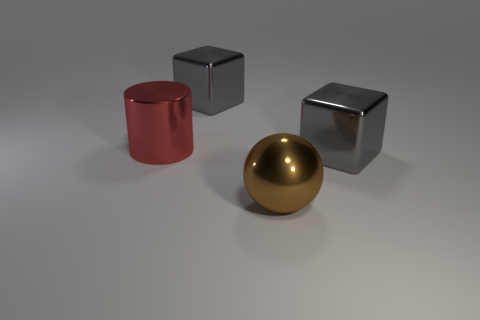Add 2 big red metal objects. How many objects exist? 6 Subtract all cylinders. How many objects are left? 3 Subtract 0 yellow balls. How many objects are left? 4 Subtract all red cylinders. Subtract all gray cubes. How many objects are left? 1 Add 2 big red metallic objects. How many big red metallic objects are left? 3 Add 1 small green matte cylinders. How many small green matte cylinders exist? 1 